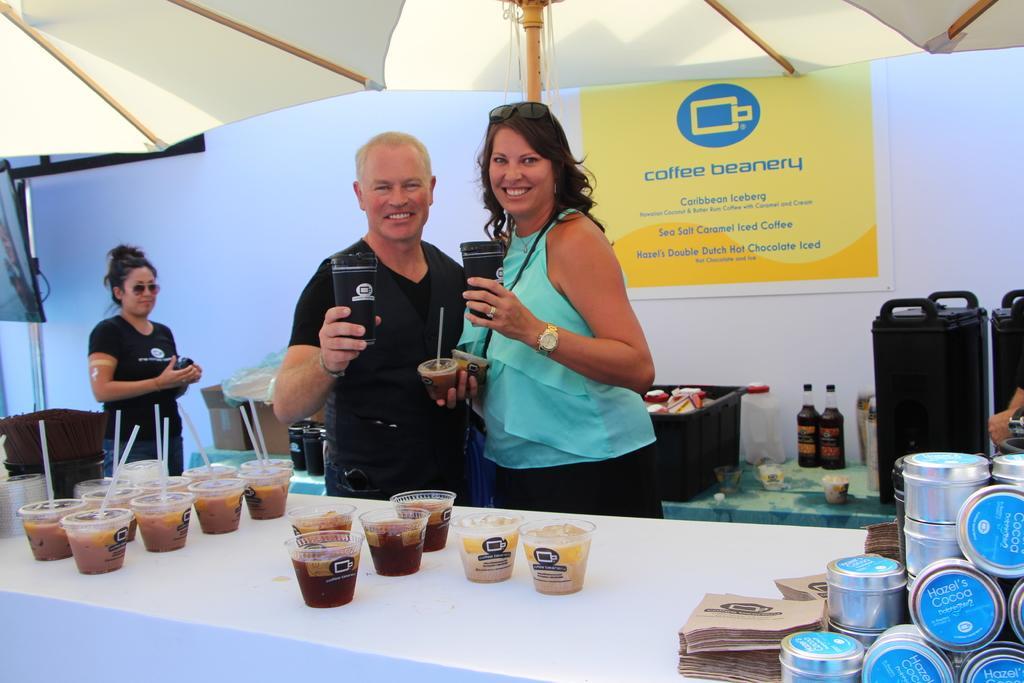Please provide a concise description of this image. In this picture we can see there are three people standing on the path and two people are holding some cups. In front of the people there is a table and on the table there are so many cups. Behind the people there is another table and on the table there are black cups, bottles, plastic container and other things and a banner. 